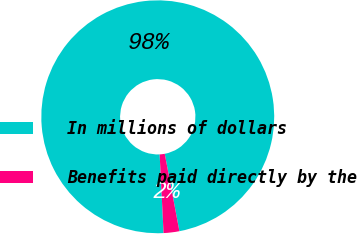Convert chart. <chart><loc_0><loc_0><loc_500><loc_500><pie_chart><fcel>In millions of dollars<fcel>Benefits paid directly by the<nl><fcel>97.82%<fcel>2.18%<nl></chart> 